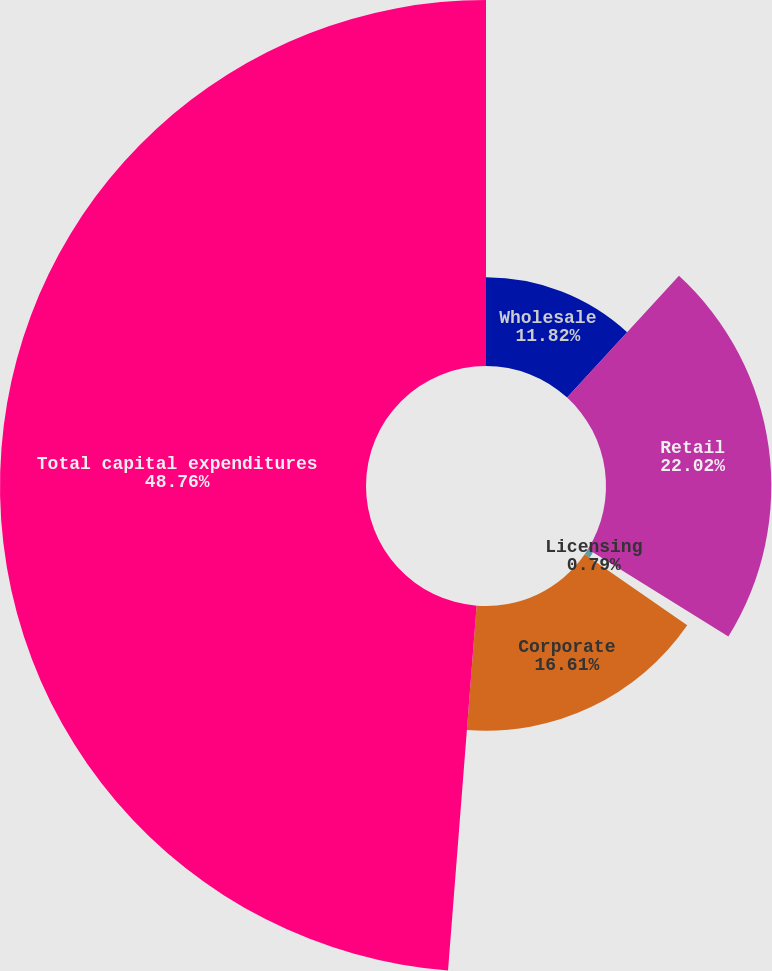<chart> <loc_0><loc_0><loc_500><loc_500><pie_chart><fcel>Wholesale<fcel>Retail<fcel>Licensing<fcel>Corporate<fcel>Total capital expenditures<nl><fcel>11.82%<fcel>22.02%<fcel>0.79%<fcel>16.61%<fcel>48.75%<nl></chart> 